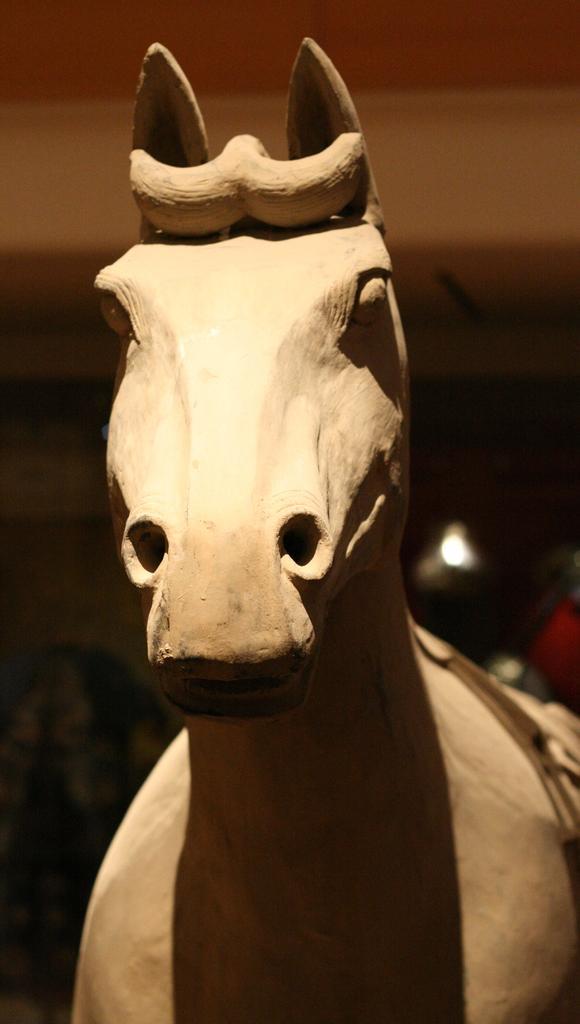How would you summarize this image in a sentence or two? In the image there is a statue of a horse in the front and the back is dark and blur. 